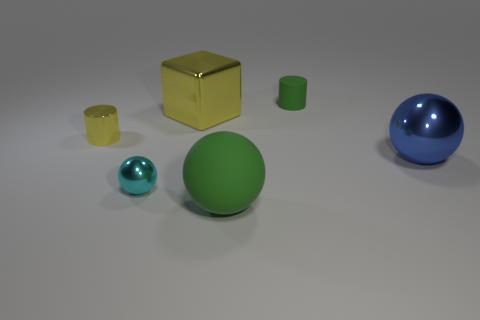Add 1 matte things. How many objects exist? 7 Subtract all blue shiny spheres. How many spheres are left? 2 Subtract all green spheres. How many spheres are left? 2 Add 2 cyan balls. How many cyan balls are left? 3 Add 1 big matte things. How many big matte things exist? 2 Subtract 0 blue cylinders. How many objects are left? 6 Subtract all blocks. How many objects are left? 5 Subtract 2 cylinders. How many cylinders are left? 0 Subtract all green spheres. Subtract all brown cylinders. How many spheres are left? 2 Subtract all purple cubes. How many brown balls are left? 0 